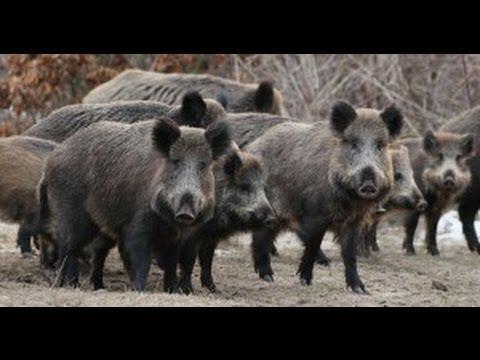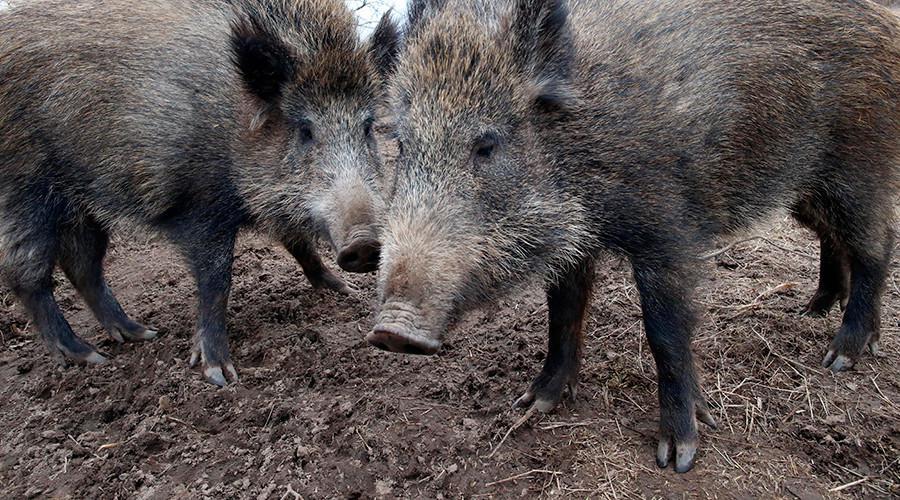The first image is the image on the left, the second image is the image on the right. Evaluate the accuracy of this statement regarding the images: "there is exactly one boar in the image on the right". Is it true? Answer yes or no. No. The first image is the image on the left, the second image is the image on the right. Considering the images on both sides, is "At least one of the images shows exactly one boar." valid? Answer yes or no. No. 